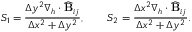<formula> <loc_0><loc_0><loc_500><loc_500>S _ { 1 } = \frac { \Delta y ^ { 2 } \nabla _ { h } \cdot \widehat { B } _ { i j } } { \Delta x ^ { 2 } + \Delta y ^ { 2 } } , \quad S _ { 2 } = \frac { \Delta x ^ { 2 } \nabla _ { h } \cdot \widehat { B } _ { i j } } { \Delta x ^ { 2 } + \Delta y ^ { 2 } } .</formula> 